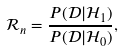Convert formula to latex. <formula><loc_0><loc_0><loc_500><loc_500>\mathcal { R } _ { n } = \frac { P ( \mathcal { D } | \mathcal { H } _ { 1 } ) } { P ( \mathcal { D } | \mathcal { H } _ { 0 } ) } ,</formula> 